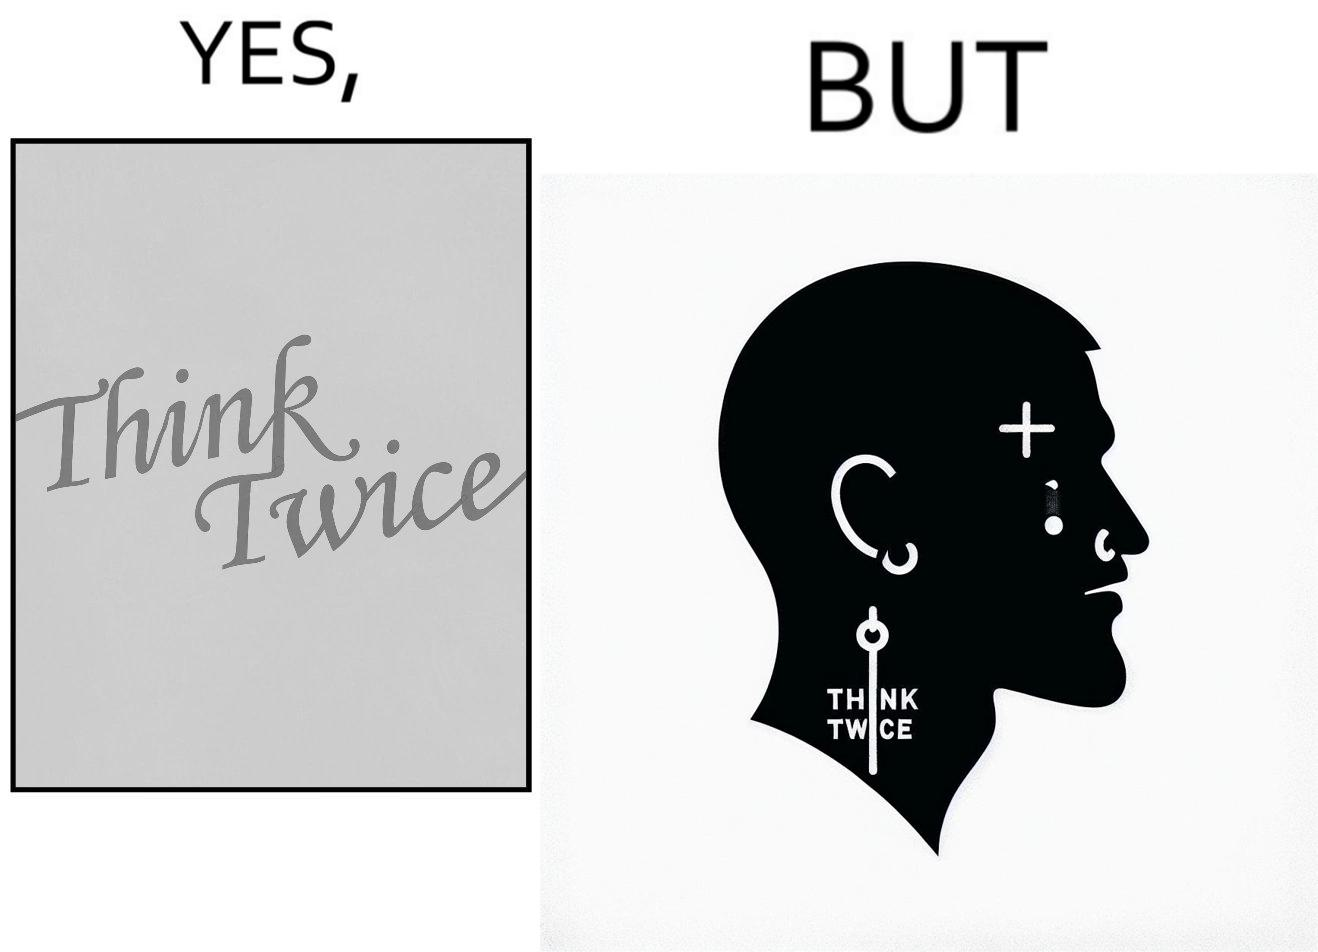Describe what you see in this image. The image is funny because even thought the tattoo on the face of the man says "think twice", the man did not think twice before getting the tattoo on his forehead. 